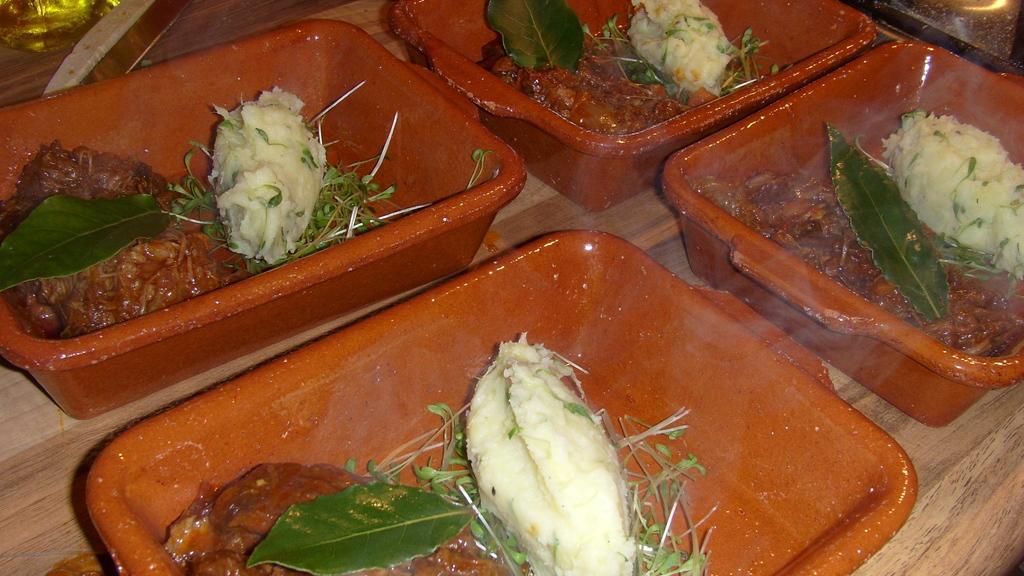Describe this image in one or two sentences. In the center of the image there are food items in the trays on the table. 